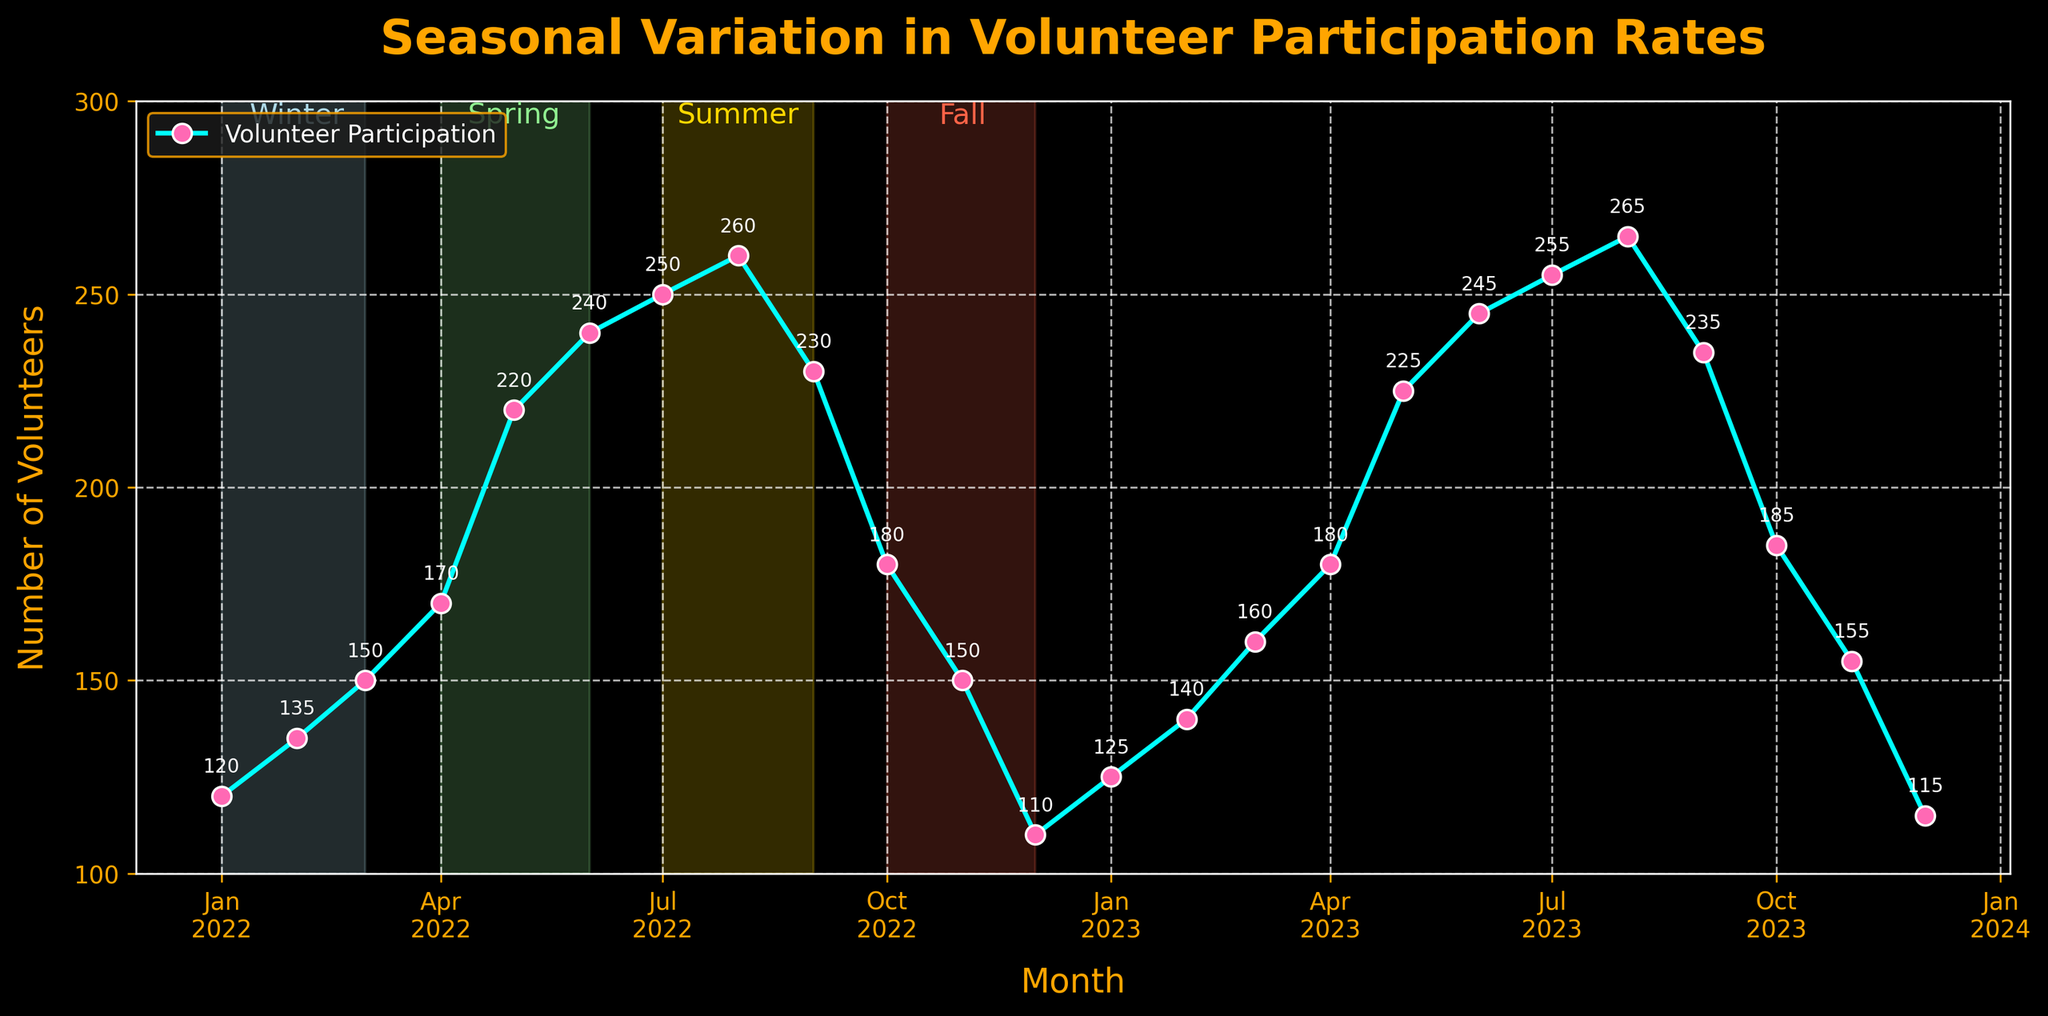How many data points are represented in the plot? The x-axis covers months from January 2022 to December 2023. Counting these months gives a total of 24 data points, each representing volunteer participation for a specific month.
Answer: 24 What is the title of the plot? The title of the plot is clearly mentioned at the top. It reads "Seasonal Variation in Volunteer Participation Rates".
Answer: Seasonal Variation in Volunteer Participation Rates In which month was the highest volunteer participation observed? The plot includes markers indicating volunteer participation for each month. Observing the highest point on the plot, the peak appears in August 2023 with a value of 265 volunteers.
Answer: August 2023 How does volunteer participation in July 2022 compare to July 2023? By examining the plot, the participation in July 2022 is shown as 250 volunteers and in July 2023 as 255 volunteers. Comparing these, July 2023 has slightly higher participation than July 2022.
Answer: July 2023 is higher What is the average volunteer participation in the summer months (June, July, and August) of 2023? The plot data for June, July, and August 2023 are 245, 255, and 265 respectively. To find the average, add these numbers (245 + 255 + 265 = 765) and divide by 3, resulting in an average of 255.
Answer: 255 What is the percentage decrease in volunteer participation from May 2023 to December 2023? In May 2023, participation is 225. In December 2023, it is 115. The decrease is 225 - 115 = 110. To find the percentage decrease: (110/225) * 100 = 48.89%.
Answer: 48.89% Which season generally shows the lowest volunteer participation? The plot has highlighted seasons with spans and labels. Observing the different seasons, winter months generally show the lower participation values, particularly December and January.
Answer: Winter What month shows the largest increase in volunteer participation compared to the previous month? Comparing month-to-month differences, the largest increase is observed from April 2022 (170) to May 2022 (220), with an increase of 50 volunteers.
Answer: May 2022 What is the trend in volunteer participation from June to November in both 2022 and 2023? From June to November in both years, volunteer participation follows a similar trend: rises in summer (June to August) and then declines into fall (September to November).
Answer: Rises and then declines 